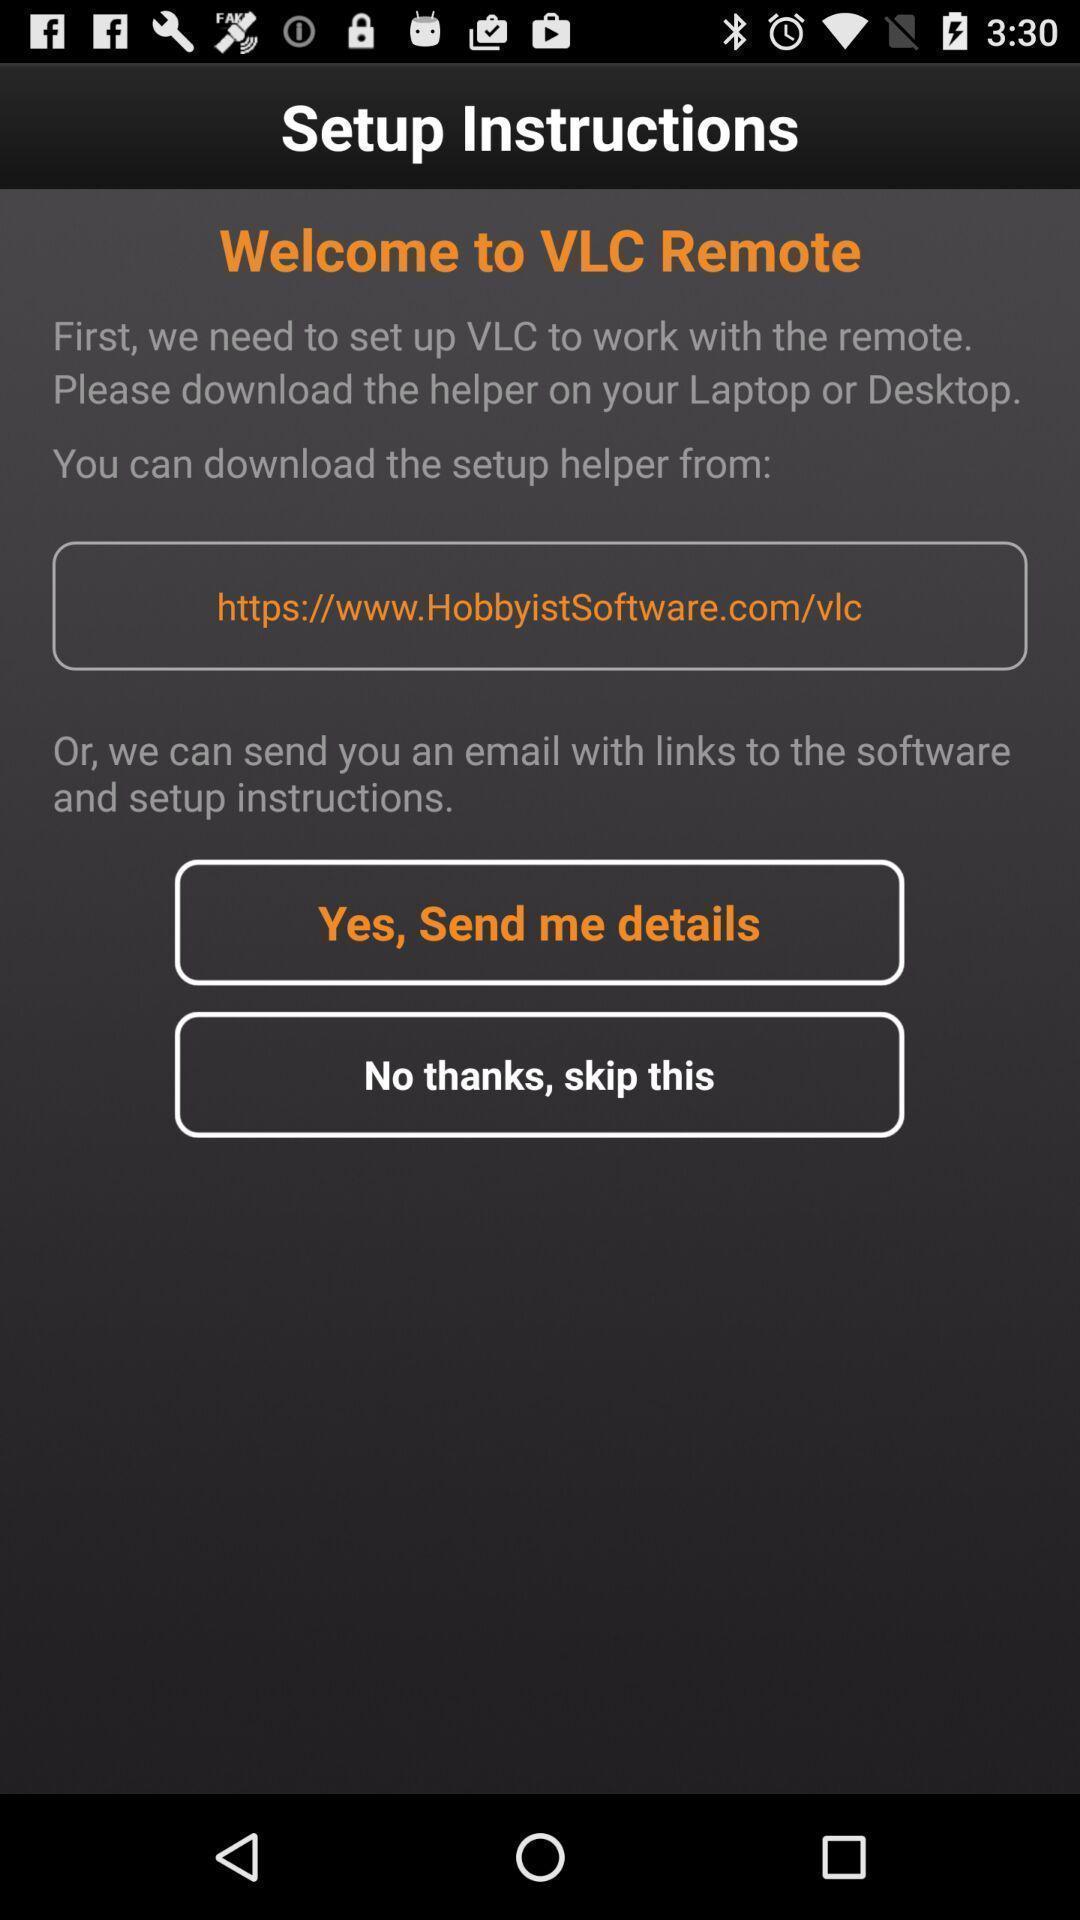Describe the content in this image. Welcome page to the application with setup instructions. 